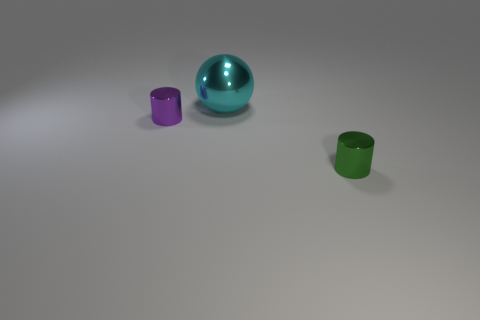Add 1 small green things. How many objects exist? 4 Subtract all cylinders. How many objects are left? 1 Add 2 spheres. How many spheres are left? 3 Add 3 tiny brown metallic cubes. How many tiny brown metallic cubes exist? 3 Subtract 0 brown balls. How many objects are left? 3 Subtract all tiny purple metal things. Subtract all green objects. How many objects are left? 1 